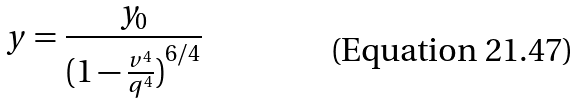<formula> <loc_0><loc_0><loc_500><loc_500>y = \frac { y _ { 0 } } { ( { 1 - \frac { v ^ { 4 } } { q ^ { 4 } } ) } ^ { 6 / 4 } }</formula> 